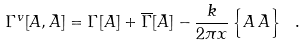Convert formula to latex. <formula><loc_0><loc_0><loc_500><loc_500>\Gamma ^ { v } [ A , \bar { A } ] = \Gamma [ A ] + \overline { \Gamma } [ \bar { A } ] - \frac { k } { 2 \pi x } \left \{ A \, \bar { A } \right \} \ .</formula> 